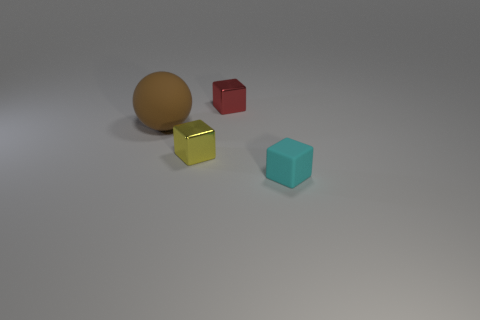There is a shiny thing that is right of the yellow shiny block; is it the same color as the rubber ball?
Offer a terse response. No. What number of small cyan rubber objects are the same shape as the tiny red metallic object?
Your answer should be very brief. 1. How many objects are either metal blocks behind the big rubber ball or small cubes in front of the small yellow shiny thing?
Your answer should be very brief. 2. How many yellow objects are either big objects or matte blocks?
Offer a terse response. 0. What is the material of the small block that is behind the small cyan block and in front of the tiny red shiny object?
Give a very brief answer. Metal. Are the yellow block and the big brown thing made of the same material?
Offer a terse response. No. How many red metallic objects have the same size as the yellow metallic cube?
Offer a terse response. 1. Are there the same number of brown matte things that are in front of the small cyan object and big yellow rubber objects?
Your response must be concise. Yes. What number of objects are both behind the big matte sphere and to the left of the red metallic block?
Keep it short and to the point. 0. Does the small metallic object that is on the left side of the red metallic object have the same shape as the red object?
Make the answer very short. Yes. 